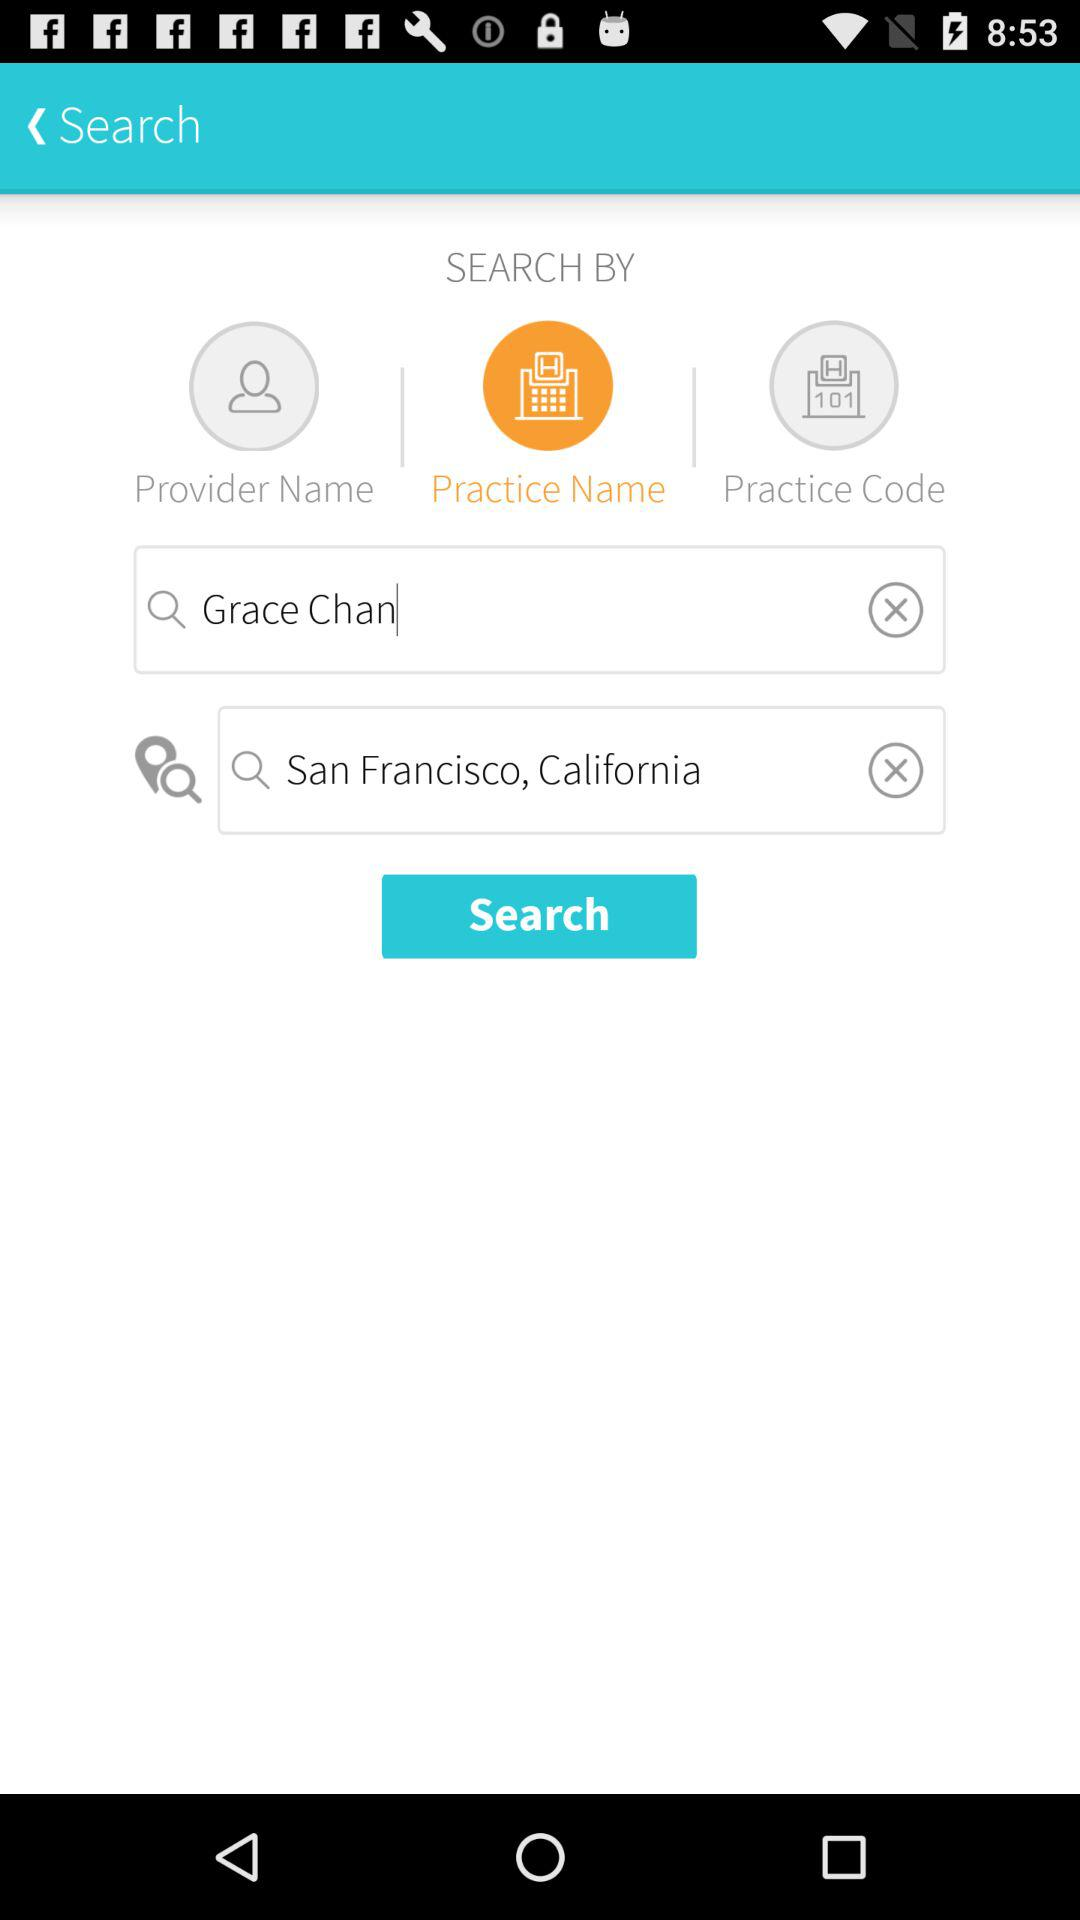What is the location? The location is San Francisco, California. 